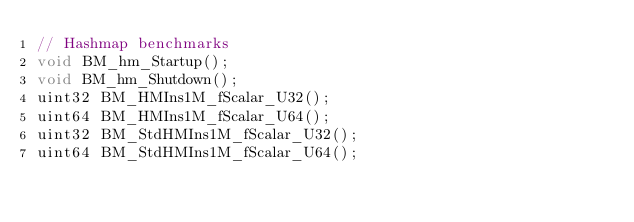<code> <loc_0><loc_0><loc_500><loc_500><_C_>// Hashmap benchmarks
void BM_hm_Startup();
void BM_hm_Shutdown();
uint32 BM_HMIns1M_fScalar_U32();
uint64 BM_HMIns1M_fScalar_U64();
uint32 BM_StdHMIns1M_fScalar_U32();
uint64 BM_StdHMIns1M_fScalar_U64();
</code> 